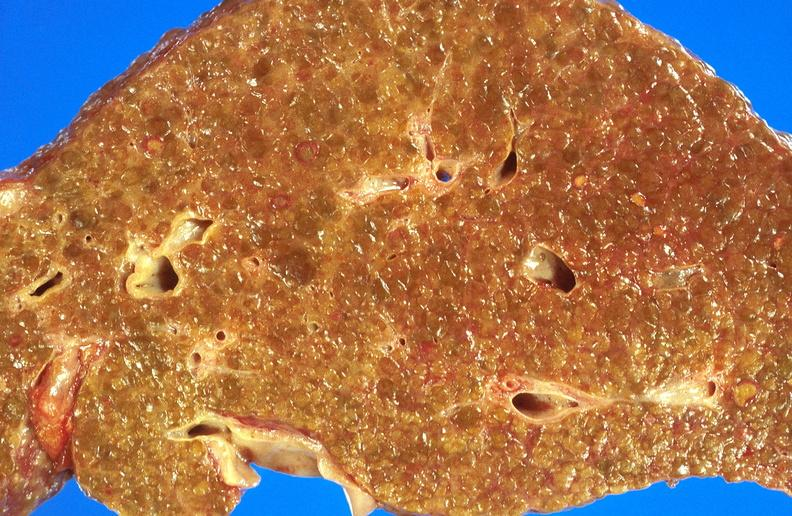does interesting case show alcoholic cirrhosis?
Answer the question using a single word or phrase. No 